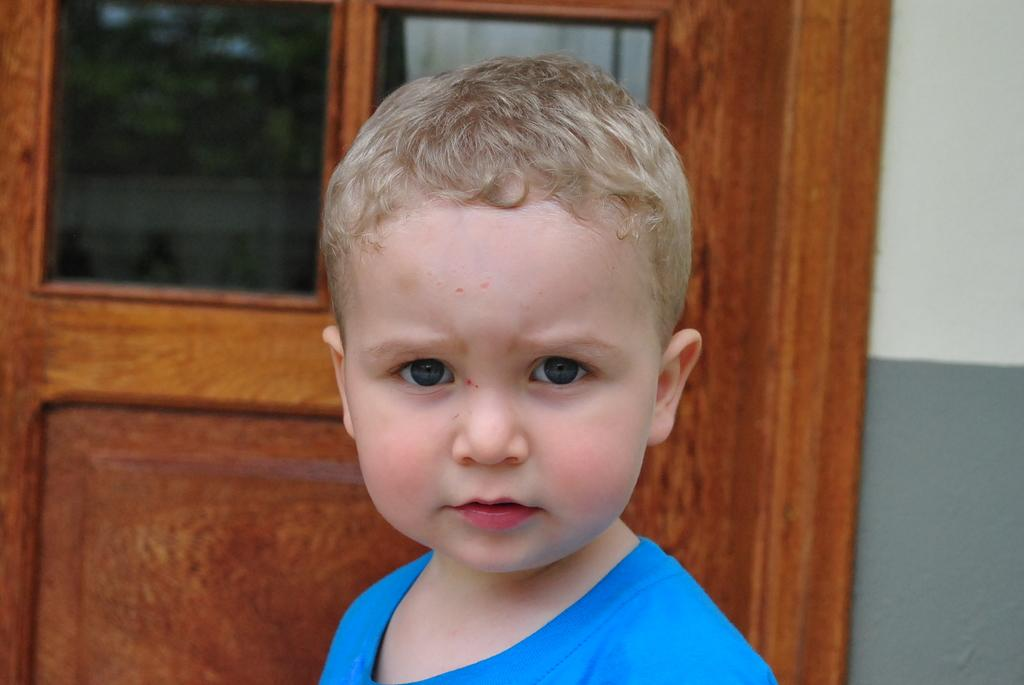Who is the main subject in the image? There is a boy in the image. What is the boy wearing? The boy is wearing a blue T-shirt. What can be seen behind the boy? There is a brown door behind the boy. What is on the right side of the image? There is a wall on the right side of the image. What colors are used for the wall? The wall is in white and grey colors. What type of question is being asked in the image? There is no question being asked in the image; it is a still photograph of a boy. 